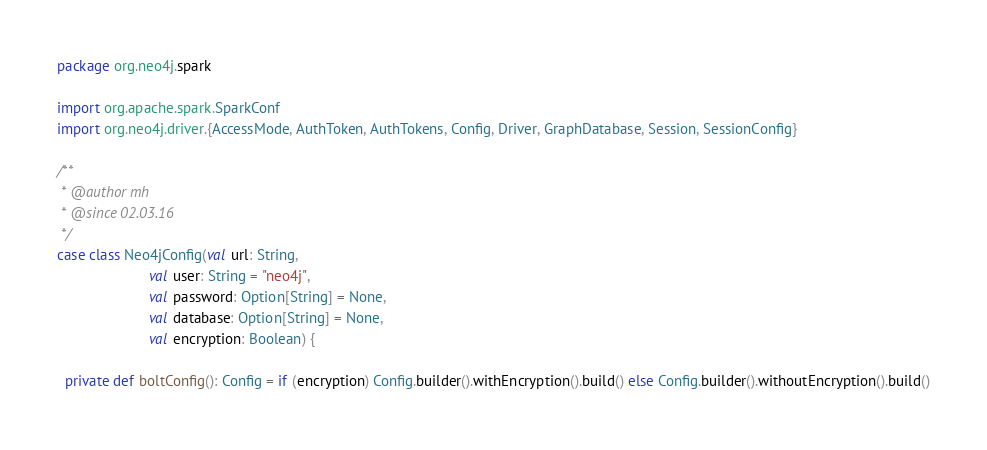<code> <loc_0><loc_0><loc_500><loc_500><_Scala_>package org.neo4j.spark

import org.apache.spark.SparkConf
import org.neo4j.driver.{AccessMode, AuthToken, AuthTokens, Config, Driver, GraphDatabase, Session, SessionConfig}

/**
 * @author mh
 * @since 02.03.16
 */
case class Neo4jConfig(val url: String,
                       val user: String = "neo4j",
                       val password: Option[String] = None,
                       val database: Option[String] = None,
                       val encryption: Boolean) {

  private def boltConfig(): Config = if (encryption) Config.builder().withEncryption().build() else Config.builder().withoutEncryption().build()
</code> 